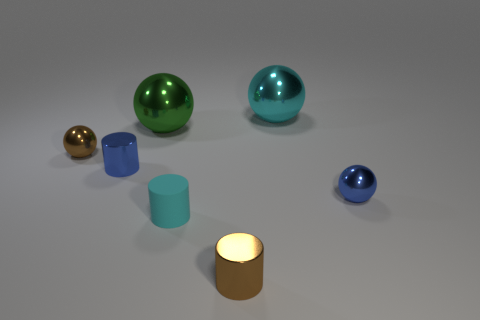There is a large shiny object left of the large cyan shiny thing; what color is it?
Your answer should be compact. Green. There is a big object that is on the left side of the cyan sphere; does it have the same shape as the small blue thing on the right side of the small cyan cylinder?
Keep it short and to the point. Yes. Are there any other brown cylinders of the same size as the brown shiny cylinder?
Offer a terse response. No. There is a blue thing in front of the tiny blue cylinder; what is its material?
Offer a very short reply. Metal. Is the material of the big object that is behind the big green sphere the same as the cyan cylinder?
Your answer should be compact. No. Are any big cyan things visible?
Provide a short and direct response. Yes. There is another large ball that is made of the same material as the big cyan ball; what is its color?
Make the answer very short. Green. What color is the small cylinder that is behind the cyan object to the left of the large sphere that is behind the big green sphere?
Offer a very short reply. Blue. Is the size of the green shiny object the same as the metallic thing to the right of the big cyan ball?
Ensure brevity in your answer.  No. How many things are either tiny brown metallic objects that are on the right side of the brown metal ball or metal spheres that are behind the small blue metal cylinder?
Offer a very short reply. 4. 